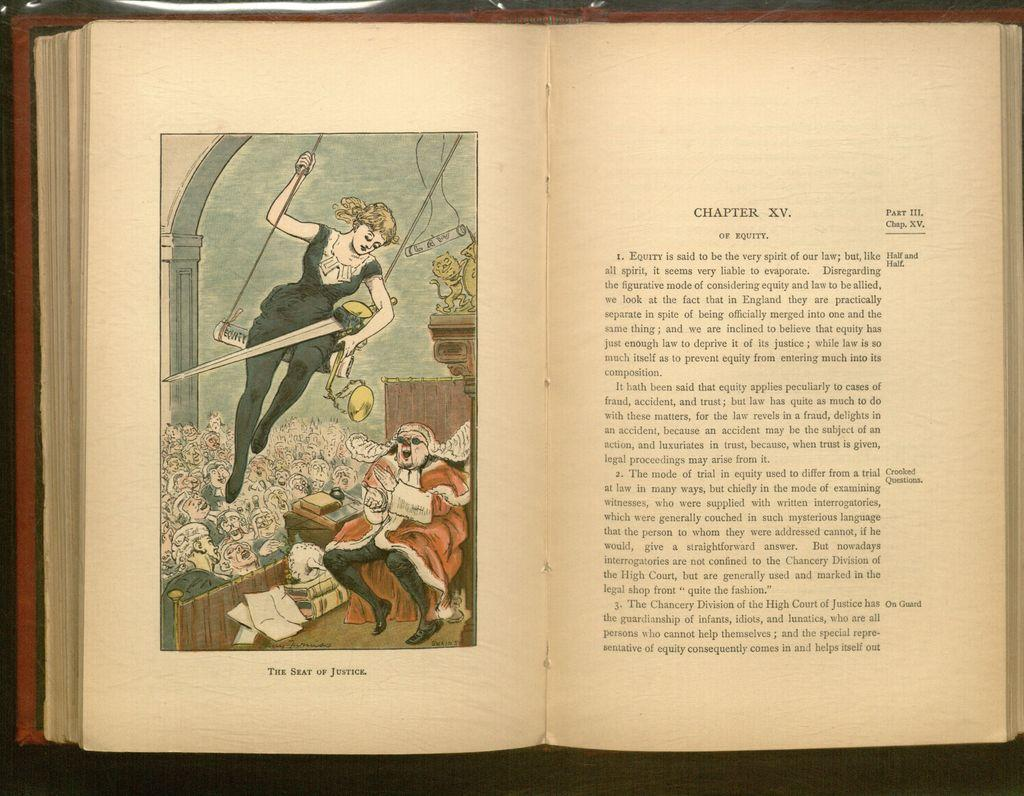<image>
Provide a brief description of the given image. An open book with an illustration of a women above the words The seat of Justice. 